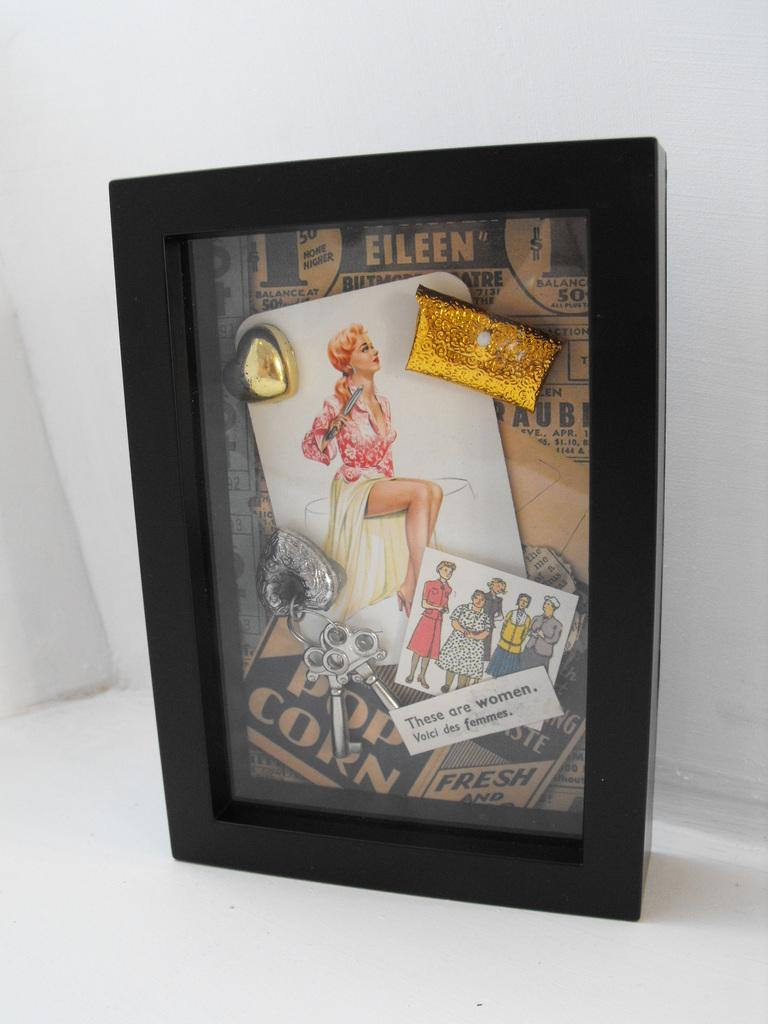<image>
Relay a brief, clear account of the picture shown. A framed picture of a woman with the word Eileen visible. 